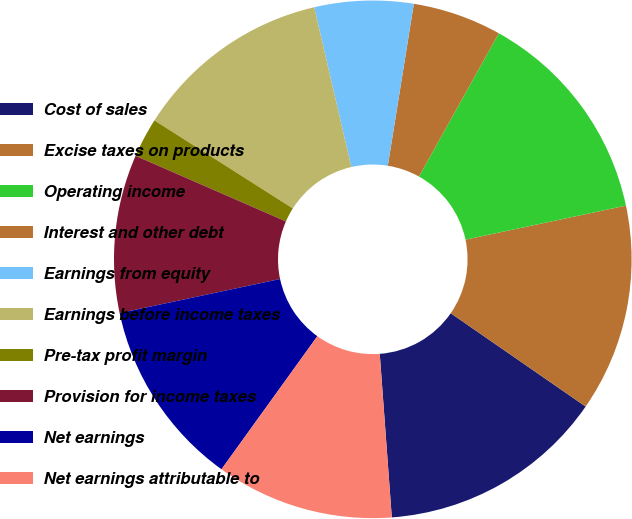<chart> <loc_0><loc_0><loc_500><loc_500><pie_chart><fcel>Cost of sales<fcel>Excise taxes on products<fcel>Operating income<fcel>Interest and other debt<fcel>Earnings from equity<fcel>Earnings before income taxes<fcel>Pre-tax profit margin<fcel>Provision for income taxes<fcel>Net earnings<fcel>Net earnings attributable to<nl><fcel>14.2%<fcel>12.96%<fcel>13.58%<fcel>5.56%<fcel>6.17%<fcel>12.35%<fcel>2.47%<fcel>9.88%<fcel>11.73%<fcel>11.11%<nl></chart> 